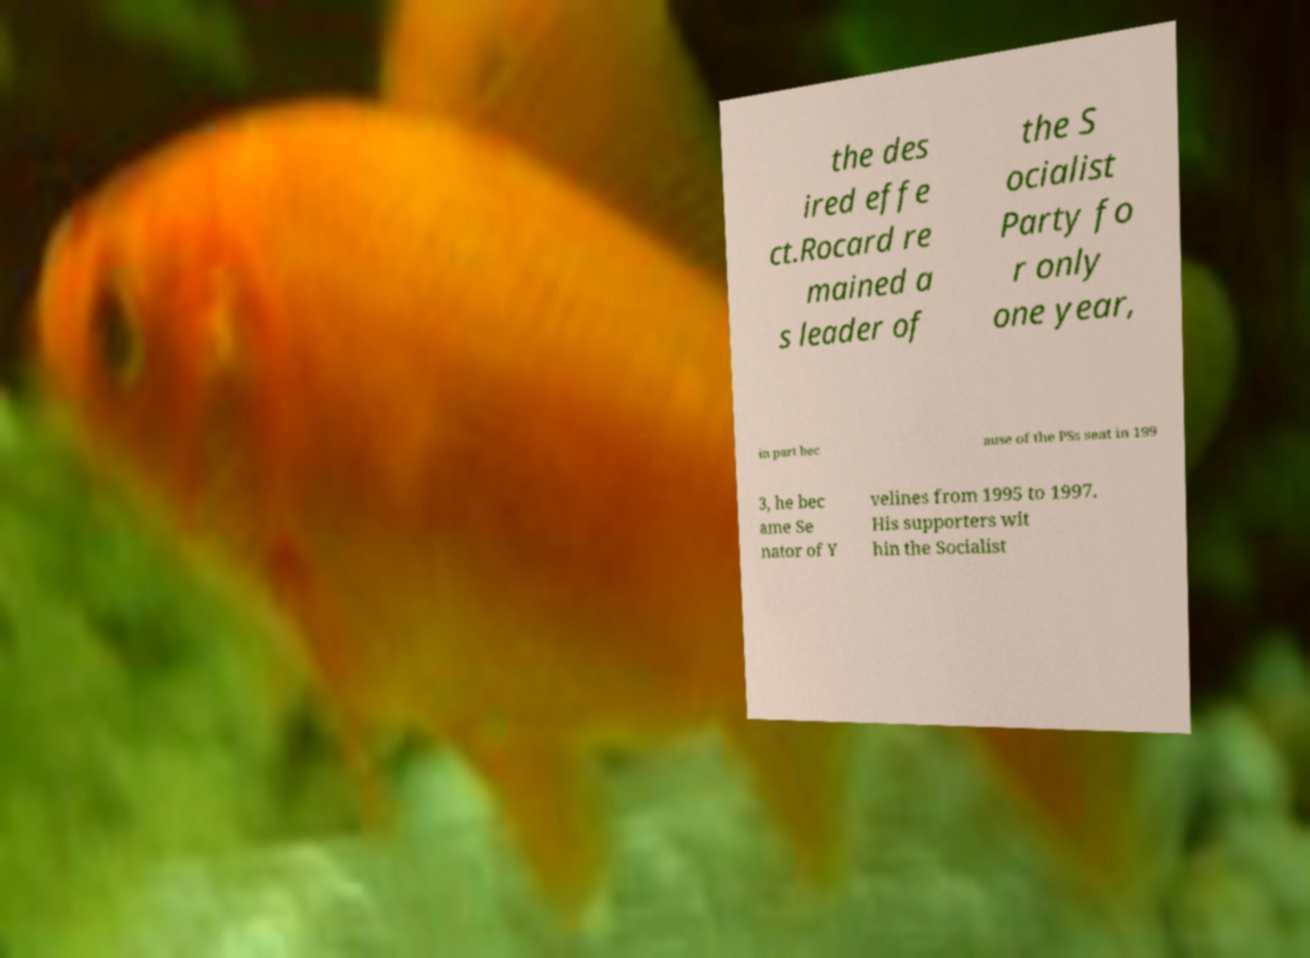For documentation purposes, I need the text within this image transcribed. Could you provide that? the des ired effe ct.Rocard re mained a s leader of the S ocialist Party fo r only one year, in part bec ause of the PSs seat in 199 3, he bec ame Se nator of Y velines from 1995 to 1997. His supporters wit hin the Socialist 